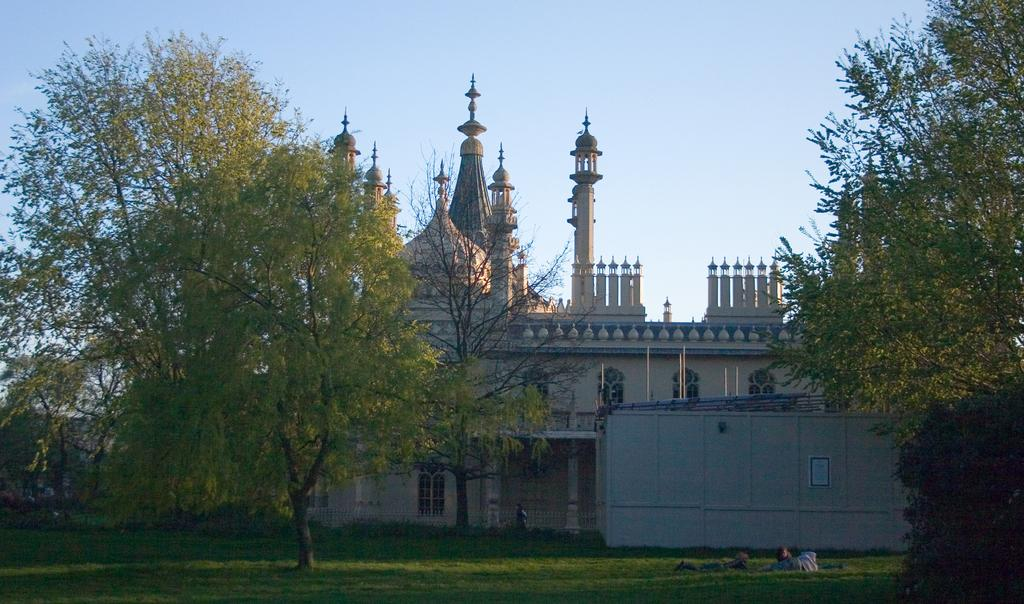What is the main structure in the middle of the picture? There is a building in the middle of the picture. What can be seen in front of the building? There are trees and grass in front of the building. What is visible in the background of the picture? The sky is visible in the background of the picture. What type of substance is being sprayed by the waves in the image? There are no waves or substances being sprayed in the image. The image features a building with trees and grass in front, and a visible sky in the background. 